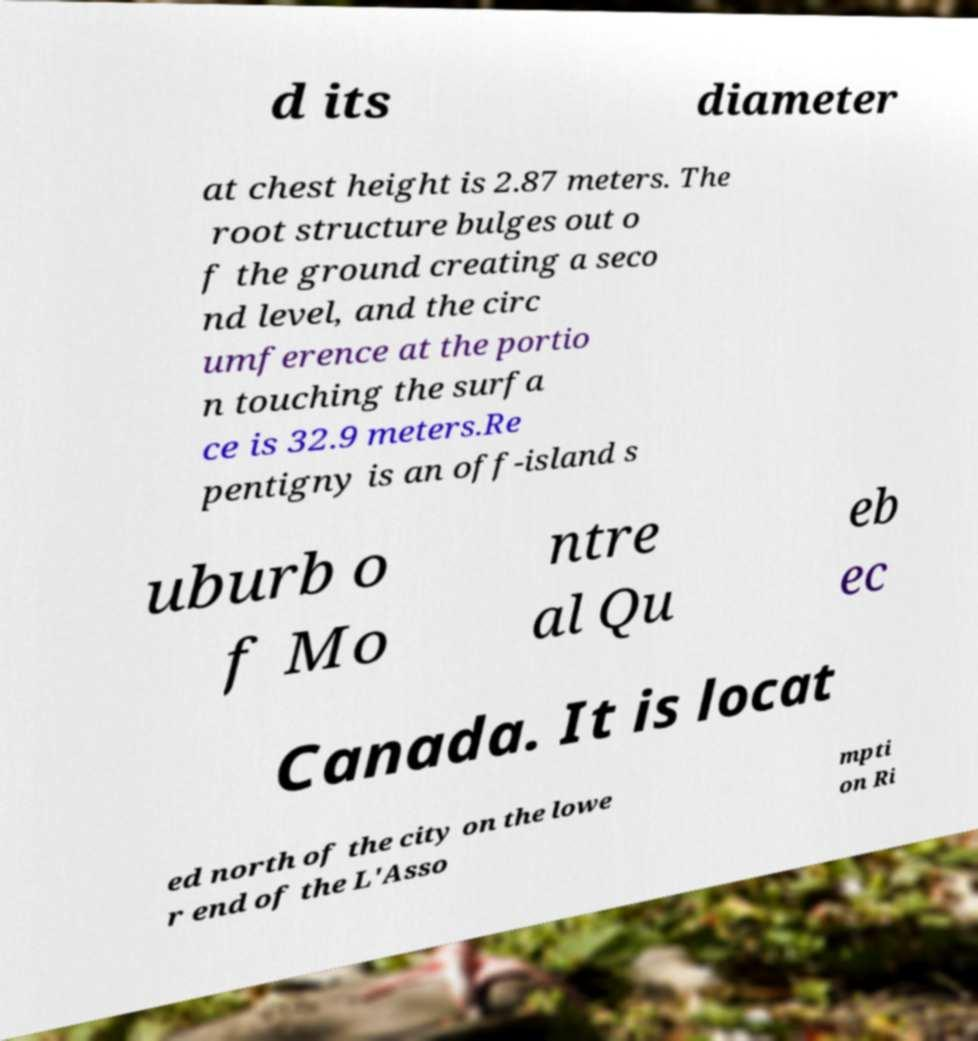Could you extract and type out the text from this image? d its diameter at chest height is 2.87 meters. The root structure bulges out o f the ground creating a seco nd level, and the circ umference at the portio n touching the surfa ce is 32.9 meters.Re pentigny is an off-island s uburb o f Mo ntre al Qu eb ec Canada. It is locat ed north of the city on the lowe r end of the L'Asso mpti on Ri 